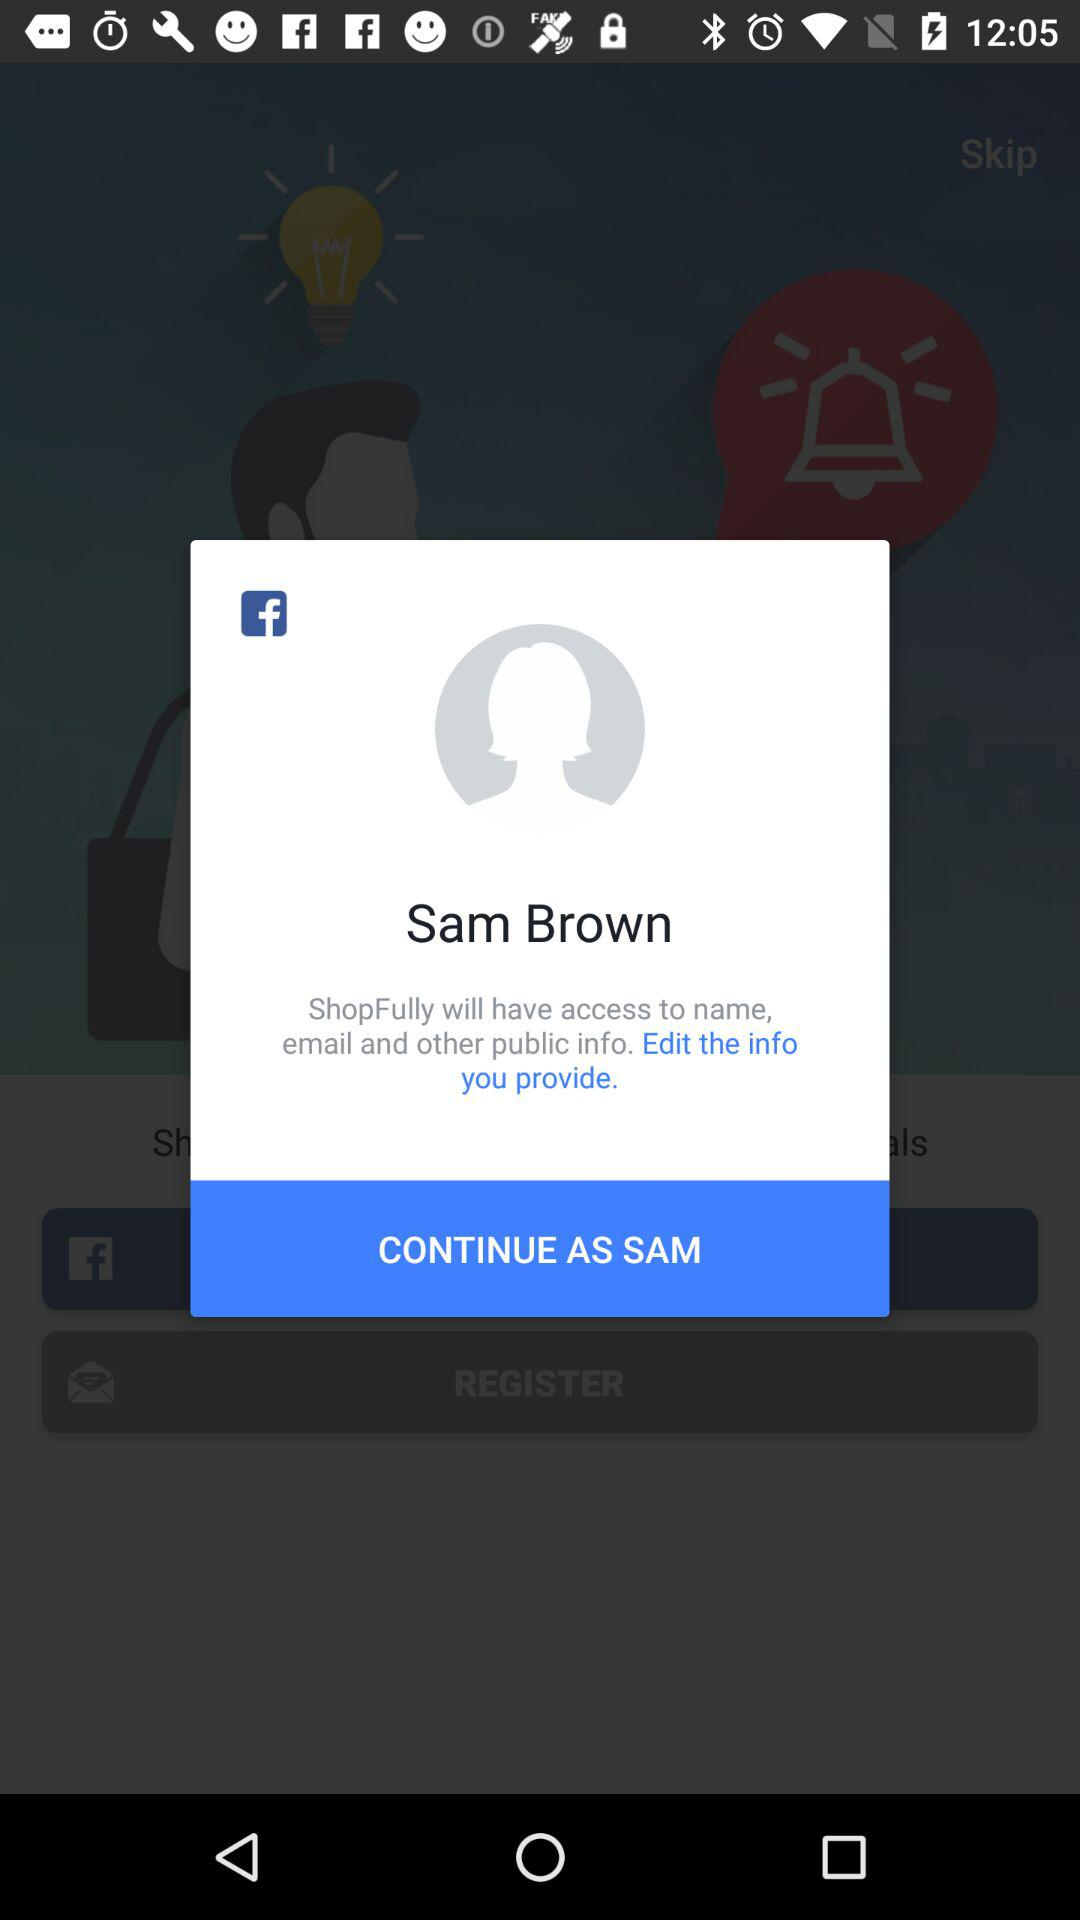What is the login name? The login name is Sam Brown. 